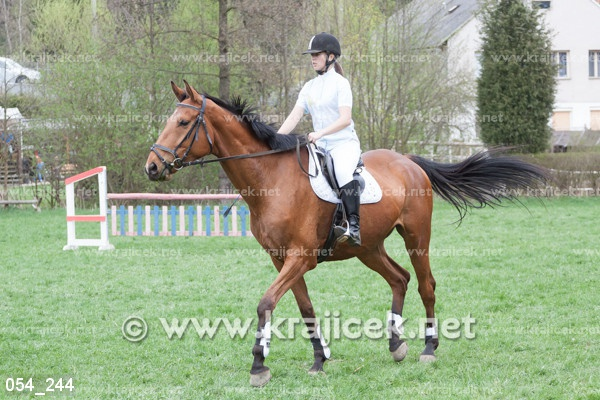Describe the objects in this image and their specific colors. I can see horse in darkgray, brown, gray, maroon, and black tones, people in darkgray, white, gray, and black tones, and car in darkgray and lightgray tones in this image. 